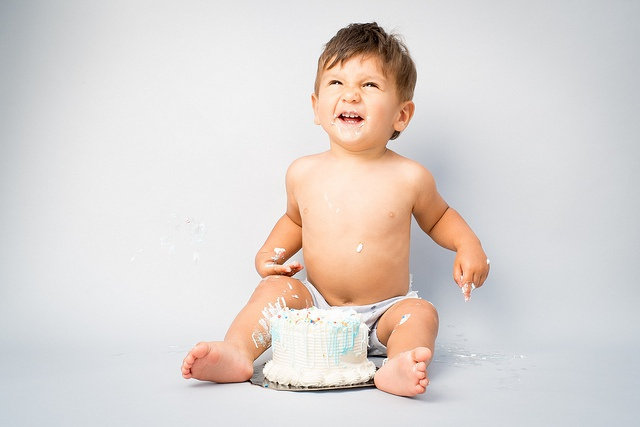Describe the objects in this image and their specific colors. I can see people in darkgray, tan, and lightgray tones and cake in darkgray, white, and tan tones in this image. 